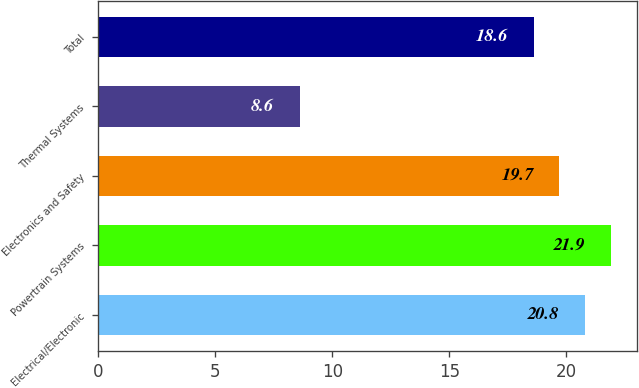Convert chart. <chart><loc_0><loc_0><loc_500><loc_500><bar_chart><fcel>Electrical/Electronic<fcel>Powertrain Systems<fcel>Electronics and Safety<fcel>Thermal Systems<fcel>Total<nl><fcel>20.8<fcel>21.9<fcel>19.7<fcel>8.6<fcel>18.6<nl></chart> 